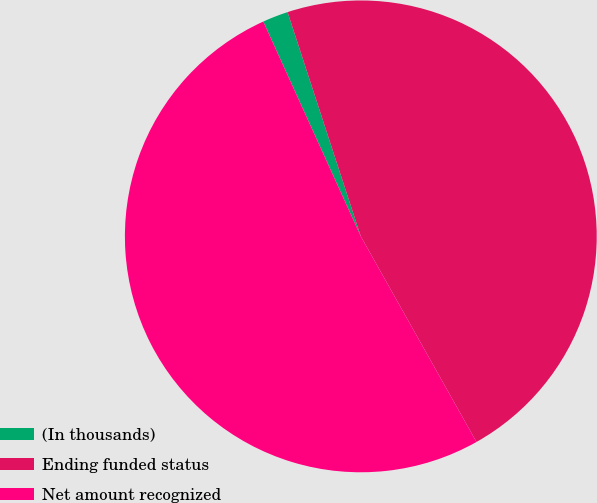Convert chart to OTSL. <chart><loc_0><loc_0><loc_500><loc_500><pie_chart><fcel>(In thousands)<fcel>Ending funded status<fcel>Net amount recognized<nl><fcel>1.76%<fcel>46.87%<fcel>51.38%<nl></chart> 